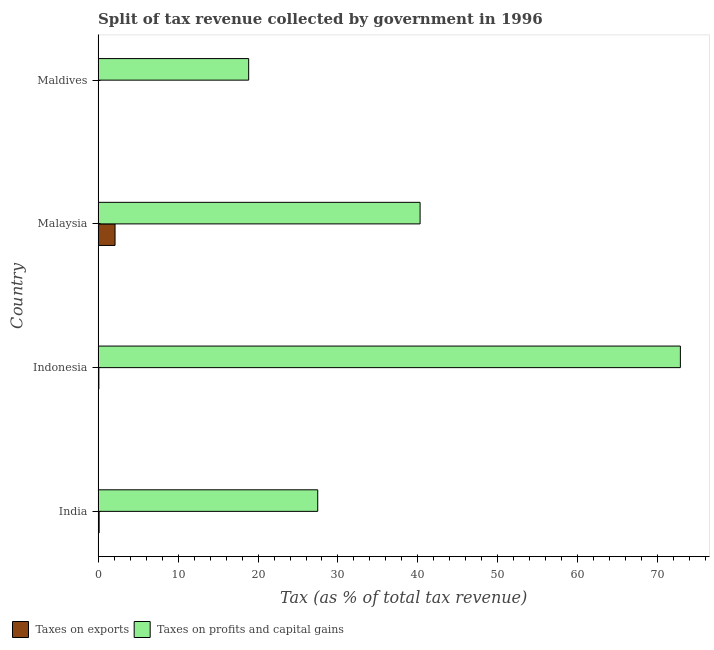How many different coloured bars are there?
Ensure brevity in your answer.  2. How many groups of bars are there?
Give a very brief answer. 4. How many bars are there on the 4th tick from the top?
Provide a short and direct response. 2. How many bars are there on the 4th tick from the bottom?
Provide a short and direct response. 2. What is the label of the 2nd group of bars from the top?
Offer a very short reply. Malaysia. What is the percentage of revenue obtained from taxes on profits and capital gains in India?
Offer a terse response. 27.47. Across all countries, what is the maximum percentage of revenue obtained from taxes on profits and capital gains?
Make the answer very short. 72.82. Across all countries, what is the minimum percentage of revenue obtained from taxes on profits and capital gains?
Offer a very short reply. 18.83. In which country was the percentage of revenue obtained from taxes on profits and capital gains maximum?
Your answer should be very brief. Indonesia. In which country was the percentage of revenue obtained from taxes on profits and capital gains minimum?
Offer a very short reply. Maldives. What is the total percentage of revenue obtained from taxes on profits and capital gains in the graph?
Provide a succinct answer. 159.39. What is the difference between the percentage of revenue obtained from taxes on profits and capital gains in India and that in Maldives?
Offer a very short reply. 8.64. What is the difference between the percentage of revenue obtained from taxes on profits and capital gains in Maldives and the percentage of revenue obtained from taxes on exports in India?
Make the answer very short. 18.7. What is the average percentage of revenue obtained from taxes on exports per country?
Provide a succinct answer. 0.59. What is the difference between the percentage of revenue obtained from taxes on exports and percentage of revenue obtained from taxes on profits and capital gains in India?
Offer a terse response. -27.34. In how many countries, is the percentage of revenue obtained from taxes on profits and capital gains greater than 74 %?
Provide a succinct answer. 0. Is the difference between the percentage of revenue obtained from taxes on exports in India and Maldives greater than the difference between the percentage of revenue obtained from taxes on profits and capital gains in India and Maldives?
Your answer should be compact. No. What is the difference between the highest and the second highest percentage of revenue obtained from taxes on profits and capital gains?
Offer a very short reply. 32.55. What is the difference between the highest and the lowest percentage of revenue obtained from taxes on profits and capital gains?
Your answer should be compact. 53.99. Is the sum of the percentage of revenue obtained from taxes on exports in Indonesia and Maldives greater than the maximum percentage of revenue obtained from taxes on profits and capital gains across all countries?
Keep it short and to the point. No. What does the 1st bar from the top in Maldives represents?
Offer a very short reply. Taxes on profits and capital gains. What does the 1st bar from the bottom in Malaysia represents?
Keep it short and to the point. Taxes on exports. How many bars are there?
Keep it short and to the point. 8. Does the graph contain any zero values?
Give a very brief answer. No. Does the graph contain grids?
Keep it short and to the point. No. What is the title of the graph?
Keep it short and to the point. Split of tax revenue collected by government in 1996. What is the label or title of the X-axis?
Give a very brief answer. Tax (as % of total tax revenue). What is the Tax (as % of total tax revenue) in Taxes on exports in India?
Ensure brevity in your answer.  0.13. What is the Tax (as % of total tax revenue) of Taxes on profits and capital gains in India?
Ensure brevity in your answer.  27.47. What is the Tax (as % of total tax revenue) of Taxes on exports in Indonesia?
Offer a very short reply. 0.09. What is the Tax (as % of total tax revenue) of Taxes on profits and capital gains in Indonesia?
Offer a terse response. 72.82. What is the Tax (as % of total tax revenue) in Taxes on exports in Malaysia?
Provide a short and direct response. 2.12. What is the Tax (as % of total tax revenue) of Taxes on profits and capital gains in Malaysia?
Keep it short and to the point. 40.27. What is the Tax (as % of total tax revenue) of Taxes on exports in Maldives?
Keep it short and to the point. 0.01. What is the Tax (as % of total tax revenue) in Taxes on profits and capital gains in Maldives?
Keep it short and to the point. 18.83. Across all countries, what is the maximum Tax (as % of total tax revenue) in Taxes on exports?
Give a very brief answer. 2.12. Across all countries, what is the maximum Tax (as % of total tax revenue) of Taxes on profits and capital gains?
Offer a terse response. 72.82. Across all countries, what is the minimum Tax (as % of total tax revenue) of Taxes on exports?
Your answer should be compact. 0.01. Across all countries, what is the minimum Tax (as % of total tax revenue) of Taxes on profits and capital gains?
Offer a very short reply. 18.83. What is the total Tax (as % of total tax revenue) in Taxes on exports in the graph?
Offer a terse response. 2.35. What is the total Tax (as % of total tax revenue) of Taxes on profits and capital gains in the graph?
Give a very brief answer. 159.39. What is the difference between the Tax (as % of total tax revenue) of Taxes on exports in India and that in Indonesia?
Your response must be concise. 0.03. What is the difference between the Tax (as % of total tax revenue) of Taxes on profits and capital gains in India and that in Indonesia?
Ensure brevity in your answer.  -45.36. What is the difference between the Tax (as % of total tax revenue) of Taxes on exports in India and that in Malaysia?
Your answer should be compact. -1.99. What is the difference between the Tax (as % of total tax revenue) in Taxes on profits and capital gains in India and that in Malaysia?
Give a very brief answer. -12.8. What is the difference between the Tax (as % of total tax revenue) in Taxes on exports in India and that in Maldives?
Your response must be concise. 0.11. What is the difference between the Tax (as % of total tax revenue) in Taxes on profits and capital gains in India and that in Maldives?
Offer a terse response. 8.64. What is the difference between the Tax (as % of total tax revenue) in Taxes on exports in Indonesia and that in Malaysia?
Give a very brief answer. -2.02. What is the difference between the Tax (as % of total tax revenue) in Taxes on profits and capital gains in Indonesia and that in Malaysia?
Provide a succinct answer. 32.55. What is the difference between the Tax (as % of total tax revenue) of Taxes on exports in Indonesia and that in Maldives?
Give a very brief answer. 0.08. What is the difference between the Tax (as % of total tax revenue) of Taxes on profits and capital gains in Indonesia and that in Maldives?
Your answer should be very brief. 53.99. What is the difference between the Tax (as % of total tax revenue) in Taxes on exports in Malaysia and that in Maldives?
Offer a very short reply. 2.1. What is the difference between the Tax (as % of total tax revenue) of Taxes on profits and capital gains in Malaysia and that in Maldives?
Give a very brief answer. 21.44. What is the difference between the Tax (as % of total tax revenue) in Taxes on exports in India and the Tax (as % of total tax revenue) in Taxes on profits and capital gains in Indonesia?
Keep it short and to the point. -72.7. What is the difference between the Tax (as % of total tax revenue) in Taxes on exports in India and the Tax (as % of total tax revenue) in Taxes on profits and capital gains in Malaysia?
Your answer should be very brief. -40.14. What is the difference between the Tax (as % of total tax revenue) in Taxes on exports in India and the Tax (as % of total tax revenue) in Taxes on profits and capital gains in Maldives?
Offer a very short reply. -18.7. What is the difference between the Tax (as % of total tax revenue) of Taxes on exports in Indonesia and the Tax (as % of total tax revenue) of Taxes on profits and capital gains in Malaysia?
Give a very brief answer. -40.18. What is the difference between the Tax (as % of total tax revenue) of Taxes on exports in Indonesia and the Tax (as % of total tax revenue) of Taxes on profits and capital gains in Maldives?
Provide a succinct answer. -18.74. What is the difference between the Tax (as % of total tax revenue) in Taxes on exports in Malaysia and the Tax (as % of total tax revenue) in Taxes on profits and capital gains in Maldives?
Offer a terse response. -16.71. What is the average Tax (as % of total tax revenue) in Taxes on exports per country?
Keep it short and to the point. 0.59. What is the average Tax (as % of total tax revenue) in Taxes on profits and capital gains per country?
Offer a terse response. 39.85. What is the difference between the Tax (as % of total tax revenue) in Taxes on exports and Tax (as % of total tax revenue) in Taxes on profits and capital gains in India?
Provide a short and direct response. -27.34. What is the difference between the Tax (as % of total tax revenue) of Taxes on exports and Tax (as % of total tax revenue) of Taxes on profits and capital gains in Indonesia?
Make the answer very short. -72.73. What is the difference between the Tax (as % of total tax revenue) in Taxes on exports and Tax (as % of total tax revenue) in Taxes on profits and capital gains in Malaysia?
Offer a terse response. -38.15. What is the difference between the Tax (as % of total tax revenue) in Taxes on exports and Tax (as % of total tax revenue) in Taxes on profits and capital gains in Maldives?
Give a very brief answer. -18.82. What is the ratio of the Tax (as % of total tax revenue) of Taxes on exports in India to that in Indonesia?
Your response must be concise. 1.36. What is the ratio of the Tax (as % of total tax revenue) of Taxes on profits and capital gains in India to that in Indonesia?
Offer a terse response. 0.38. What is the ratio of the Tax (as % of total tax revenue) of Taxes on exports in India to that in Malaysia?
Make the answer very short. 0.06. What is the ratio of the Tax (as % of total tax revenue) of Taxes on profits and capital gains in India to that in Malaysia?
Make the answer very short. 0.68. What is the ratio of the Tax (as % of total tax revenue) in Taxes on exports in India to that in Maldives?
Provide a succinct answer. 9.08. What is the ratio of the Tax (as % of total tax revenue) of Taxes on profits and capital gains in India to that in Maldives?
Ensure brevity in your answer.  1.46. What is the ratio of the Tax (as % of total tax revenue) in Taxes on exports in Indonesia to that in Malaysia?
Provide a succinct answer. 0.04. What is the ratio of the Tax (as % of total tax revenue) of Taxes on profits and capital gains in Indonesia to that in Malaysia?
Your answer should be compact. 1.81. What is the ratio of the Tax (as % of total tax revenue) of Taxes on exports in Indonesia to that in Maldives?
Your answer should be compact. 6.67. What is the ratio of the Tax (as % of total tax revenue) in Taxes on profits and capital gains in Indonesia to that in Maldives?
Make the answer very short. 3.87. What is the ratio of the Tax (as % of total tax revenue) of Taxes on exports in Malaysia to that in Maldives?
Offer a terse response. 150.98. What is the ratio of the Tax (as % of total tax revenue) of Taxes on profits and capital gains in Malaysia to that in Maldives?
Ensure brevity in your answer.  2.14. What is the difference between the highest and the second highest Tax (as % of total tax revenue) in Taxes on exports?
Provide a short and direct response. 1.99. What is the difference between the highest and the second highest Tax (as % of total tax revenue) in Taxes on profits and capital gains?
Offer a very short reply. 32.55. What is the difference between the highest and the lowest Tax (as % of total tax revenue) in Taxes on exports?
Make the answer very short. 2.1. What is the difference between the highest and the lowest Tax (as % of total tax revenue) of Taxes on profits and capital gains?
Your response must be concise. 53.99. 